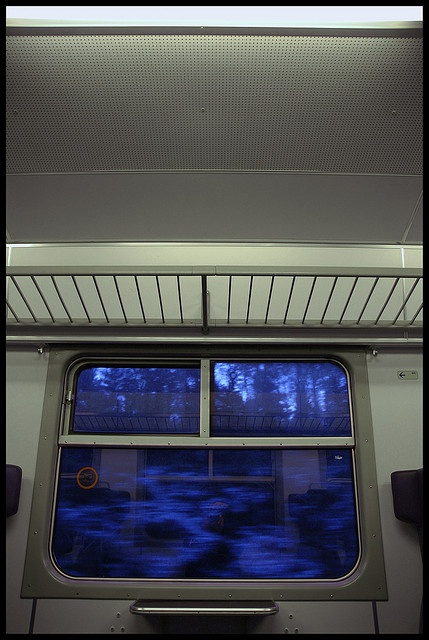Describe the objects in this image and their specific colors. I can see various objects in this image with different colors. 